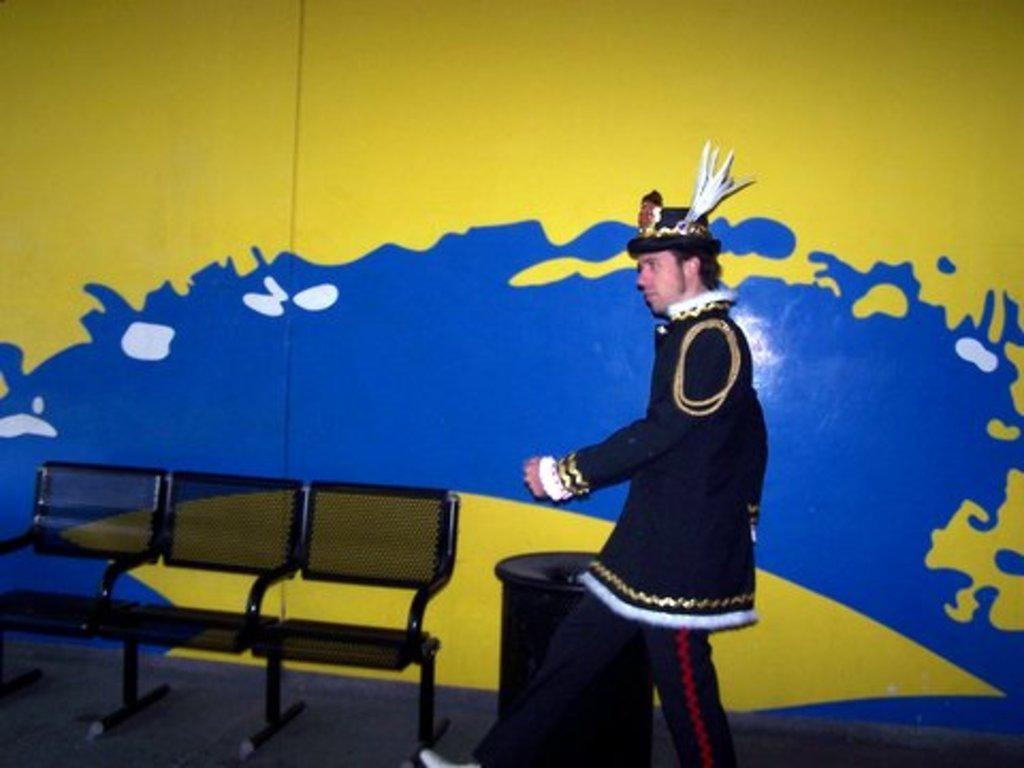Could you give a brief overview of what you see in this image? On the left side of the image we can see chairs and a wall which is painted with yellow and blue in color. On the right side of the image we can see a person is walking and wore a different type of dress. 